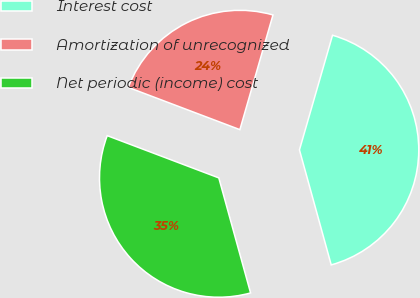Convert chart to OTSL. <chart><loc_0><loc_0><loc_500><loc_500><pie_chart><fcel>Interest cost<fcel>Amortization of unrecognized<fcel>Net periodic (income) cost<nl><fcel>41.24%<fcel>23.71%<fcel>35.05%<nl></chart> 